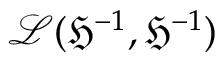Convert formula to latex. <formula><loc_0><loc_0><loc_500><loc_500>\mathcal { L } ( \mathfrak { H } ^ { - 1 } , \mathfrak { H } ^ { - 1 } )</formula> 